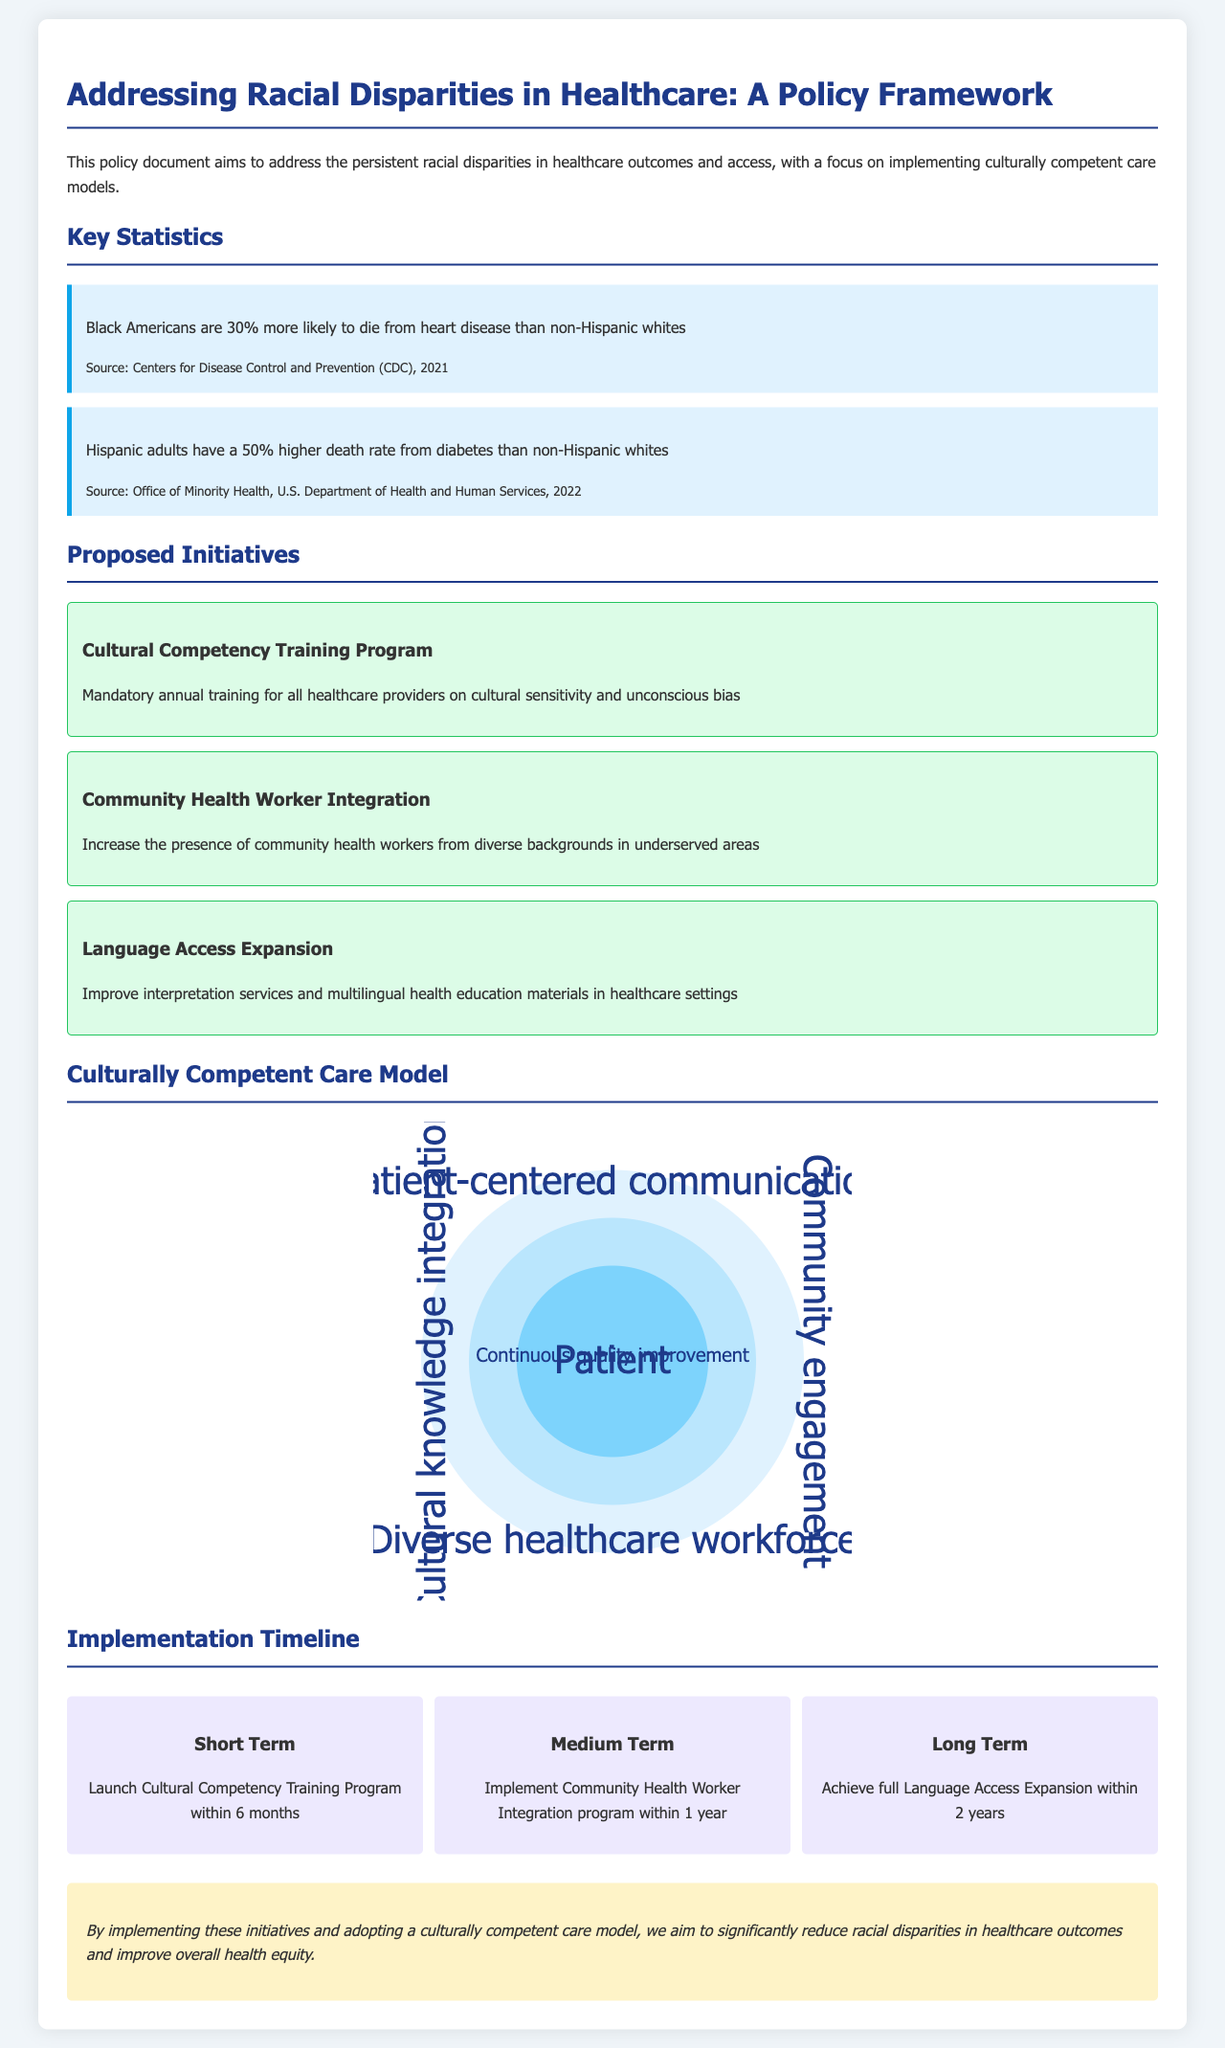What is the title of the policy document? The title of the policy document summarizes the main focus on racial disparities in healthcare.
Answer: Addressing Racial Disparities in Healthcare: A Policy Framework What percentage more likely are Black Americans to die from heart disease compared to non-Hispanic whites? This statistic highlights the increased risk faced by Black Americans in healthcare outcomes.
Answer: 30% Which government department provided the statistic about Hispanic adults and diabetes? The citation indicates the source of the statistic regarding the death rate from diabetes among Hispanic adults.
Answer: U.S. Department of Health and Human Services What is the first proposed initiative mentioned in the document? This initiative aims to enhance the cultural competency of healthcare providers.
Answer: Cultural Competency Training Program What is the duration to launch the Cultural Competency Training Program? This detail discusses the expected time frame for implementing the first initiative.
Answer: 6 months What is the focus of the community engagement in the care model? The care model emphasizes the role of community involvement in improving healthcare delivery.
Answer: Community engagement How long is the timeline for achieving full Language Access Expansion? This timeframe indicates the long-term goal for improving language services in healthcare settings.
Answer: 2 years What color represents the Patient in the culturally competent care model? The specific representation color in the model illustrates the central focus on the patient.
Answer: Light blue What type of document is this? This document type outlines specific policies and initiatives for addressing a critical social issue.
Answer: Policy document 